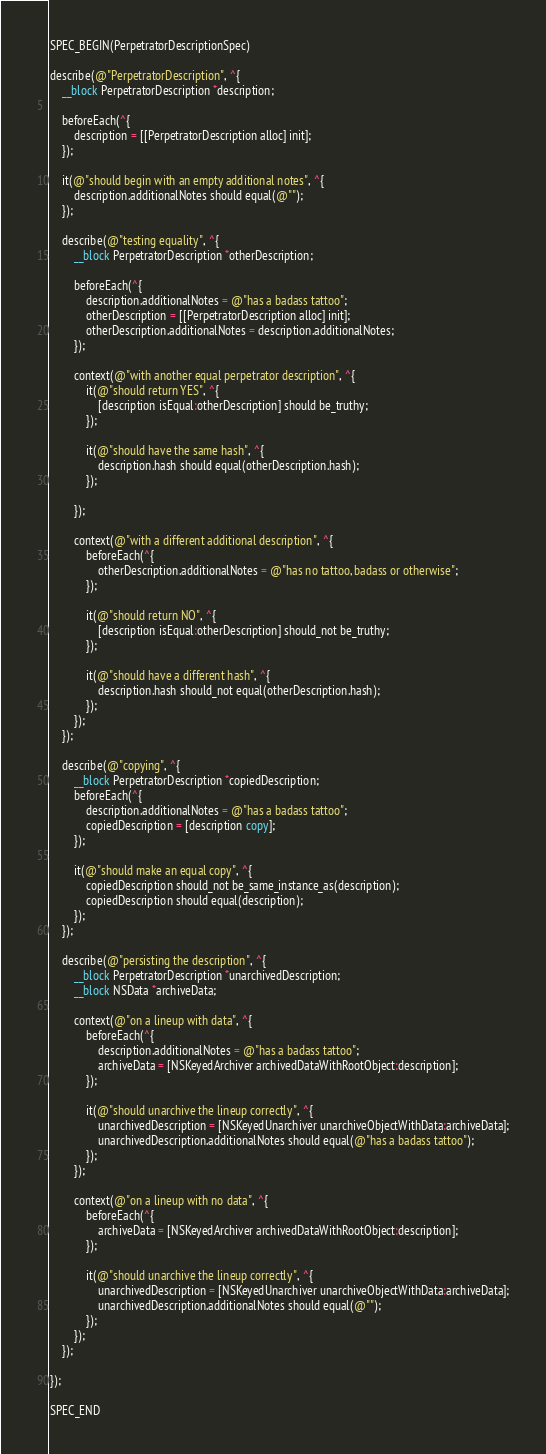Convert code to text. <code><loc_0><loc_0><loc_500><loc_500><_ObjectiveC_>SPEC_BEGIN(PerpetratorDescriptionSpec)

describe(@"PerpetratorDescription", ^{
    __block PerpetratorDescription *description;

    beforeEach(^{
        description = [[PerpetratorDescription alloc] init];
    });

    it(@"should begin with an empty additional notes", ^{
        description.additionalNotes should equal(@"");
    });

    describe(@"testing equality", ^{
        __block PerpetratorDescription *otherDescription;

        beforeEach(^{
            description.additionalNotes = @"has a badass tattoo";
            otherDescription = [[PerpetratorDescription alloc] init];
            otherDescription.additionalNotes = description.additionalNotes;
        });

        context(@"with another equal perpetrator description", ^{
            it(@"should return YES", ^{
                [description isEqual:otherDescription] should be_truthy;
            });

            it(@"should have the same hash", ^{
                description.hash should equal(otherDescription.hash);
            });

        });

        context(@"with a different additional description", ^{
            beforeEach(^{
                otherDescription.additionalNotes = @"has no tattoo, badass or otherwise";
            });

            it(@"should return NO", ^{
                [description isEqual:otherDescription] should_not be_truthy;
            });

            it(@"should have a different hash", ^{
                description.hash should_not equal(otherDescription.hash);
            });
        });
    });

    describe(@"copying", ^{
        __block PerpetratorDescription *copiedDescription;
        beforeEach(^{
            description.additionalNotes = @"has a badass tattoo";
            copiedDescription = [description copy];
        });

        it(@"should make an equal copy", ^{
            copiedDescription should_not be_same_instance_as(description);
            copiedDescription should equal(description);
        });
    });

    describe(@"persisting the description", ^{
        __block PerpetratorDescription *unarchivedDescription;
        __block NSData *archiveData;

        context(@"on a lineup with data", ^{
            beforeEach(^{
                description.additionalNotes = @"has a badass tattoo";
                archiveData = [NSKeyedArchiver archivedDataWithRootObject:description];
            });

            it(@"should unarchive the lineup correctly", ^{
                unarchivedDescription = [NSKeyedUnarchiver unarchiveObjectWithData:archiveData];
                unarchivedDescription.additionalNotes should equal(@"has a badass tattoo");
            });
        });

        context(@"on a lineup with no data", ^{
            beforeEach(^{
                archiveData = [NSKeyedArchiver archivedDataWithRootObject:description];
            });

            it(@"should unarchive the lineup correctly", ^{
                unarchivedDescription = [NSKeyedUnarchiver unarchiveObjectWithData:archiveData];
                unarchivedDescription.additionalNotes should equal(@"");
            });
        });
    });
    
});

SPEC_END
</code> 